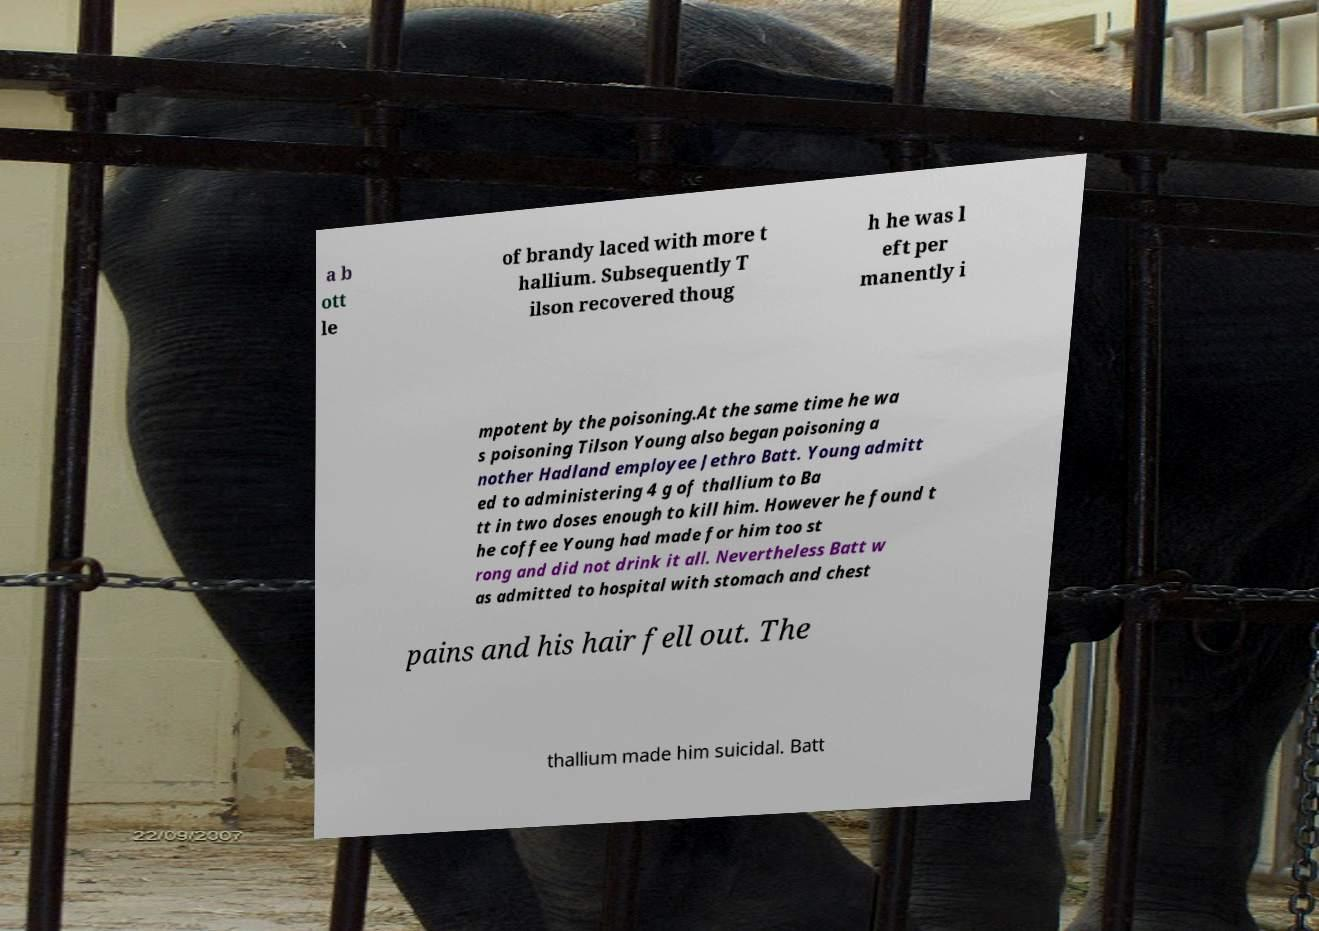Could you assist in decoding the text presented in this image and type it out clearly? a b ott le of brandy laced with more t hallium. Subsequently T ilson recovered thoug h he was l eft per manently i mpotent by the poisoning.At the same time he wa s poisoning Tilson Young also began poisoning a nother Hadland employee Jethro Batt. Young admitt ed to administering 4 g of thallium to Ba tt in two doses enough to kill him. However he found t he coffee Young had made for him too st rong and did not drink it all. Nevertheless Batt w as admitted to hospital with stomach and chest pains and his hair fell out. The thallium made him suicidal. Batt 